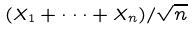Convert formula to latex. <formula><loc_0><loc_0><loc_500><loc_500>( X _ { 1 } + \cdot \cdot \cdot + X _ { n } ) / \sqrt { n }</formula> 